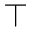Convert formula to latex. <formula><loc_0><loc_0><loc_500><loc_500>\top</formula> 